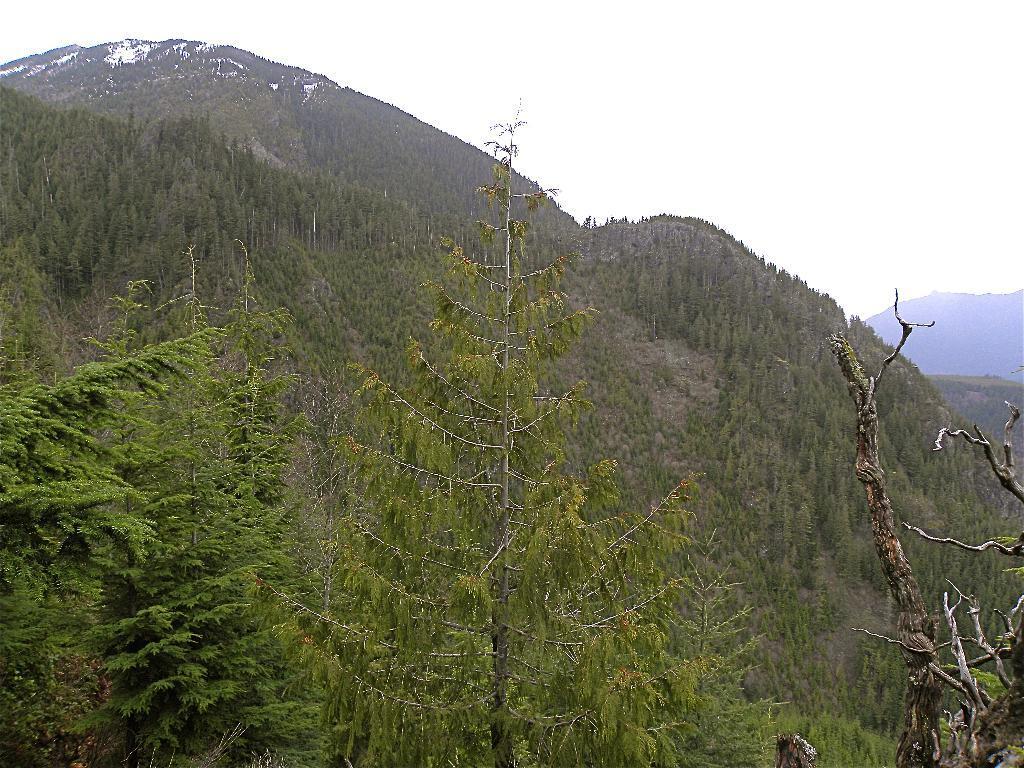Please provide a concise description of this image. In this image we can see trees. In the back there are hills. In the background there is sky. 